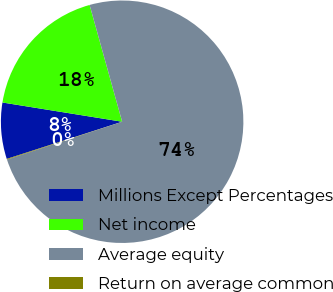Convert chart to OTSL. <chart><loc_0><loc_0><loc_500><loc_500><pie_chart><fcel>Millions Except Percentages<fcel>Net income<fcel>Average equity<fcel>Return on average common<nl><fcel>7.5%<fcel>18.14%<fcel>74.27%<fcel>0.09%<nl></chart> 